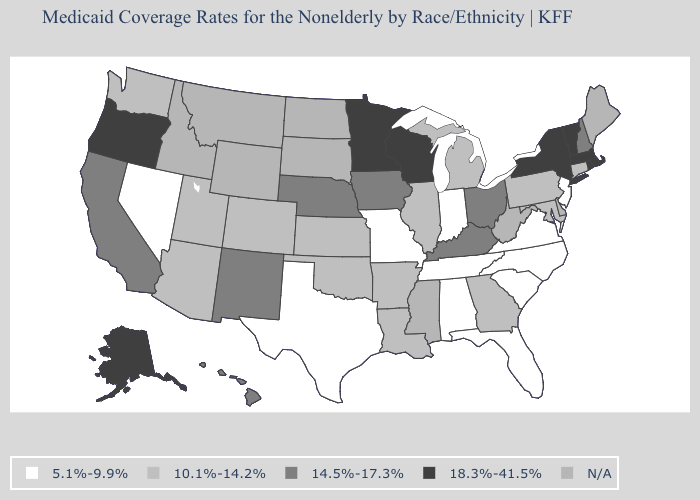Name the states that have a value in the range N/A?
Quick response, please. Delaware, Idaho, Maine, Mississippi, Montana, North Dakota, South Dakota, West Virginia, Wyoming. What is the lowest value in the South?
Concise answer only. 5.1%-9.9%. Does Massachusetts have the highest value in the USA?
Short answer required. Yes. Is the legend a continuous bar?
Quick response, please. No. Does Virginia have the lowest value in the USA?
Write a very short answer. Yes. Name the states that have a value in the range 14.5%-17.3%?
Quick response, please. California, Hawaii, Iowa, Kentucky, Nebraska, New Hampshire, New Mexico, Ohio. What is the lowest value in the West?
Concise answer only. 5.1%-9.9%. How many symbols are there in the legend?
Write a very short answer. 5. Which states have the lowest value in the MidWest?
Give a very brief answer. Indiana, Missouri. What is the highest value in states that border Alabama?
Quick response, please. 10.1%-14.2%. Name the states that have a value in the range 5.1%-9.9%?
Write a very short answer. Alabama, Florida, Indiana, Missouri, Nevada, New Jersey, North Carolina, South Carolina, Tennessee, Texas, Virginia. Name the states that have a value in the range N/A?
Write a very short answer. Delaware, Idaho, Maine, Mississippi, Montana, North Dakota, South Dakota, West Virginia, Wyoming. What is the value of Alabama?
Keep it brief. 5.1%-9.9%. What is the lowest value in states that border Maine?
Give a very brief answer. 14.5%-17.3%. What is the highest value in the USA?
Answer briefly. 18.3%-41.5%. 